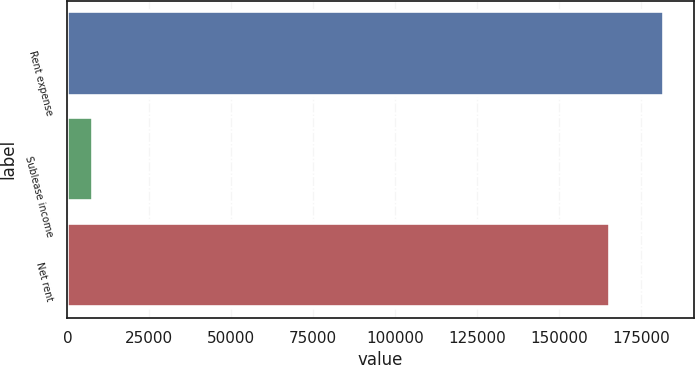Convert chart. <chart><loc_0><loc_0><loc_500><loc_500><bar_chart><fcel>Rent expense<fcel>Sublease income<fcel>Net rent<nl><fcel>181969<fcel>7914<fcel>165426<nl></chart> 